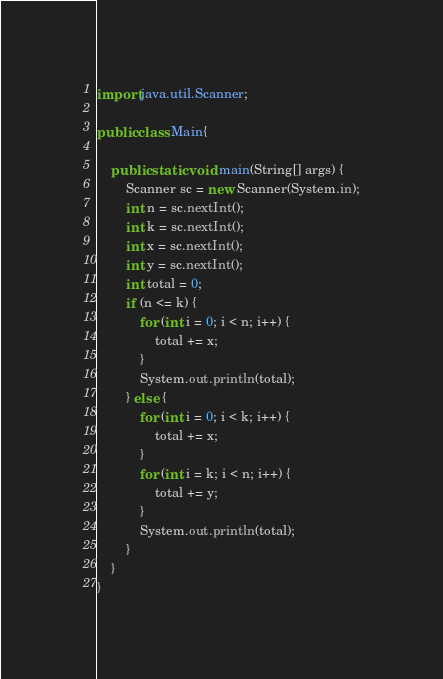Convert code to text. <code><loc_0><loc_0><loc_500><loc_500><_Java_>

import java.util.Scanner;

public class Main{

	public static void main(String[] args) {
		Scanner sc = new Scanner(System.in);
		int n = sc.nextInt();
		int k = sc.nextInt();
		int x = sc.nextInt();
		int y = sc.nextInt();
		int total = 0;
		if (n <= k) {
			for (int i = 0; i < n; i++) {
				total += x;
			}
			System.out.println(total);
		} else {
			for (int i = 0; i < k; i++) {
				total += x;
			}
			for (int i = k; i < n; i++) {
				total += y;
			}
			System.out.println(total);
		}
	}
}
</code> 